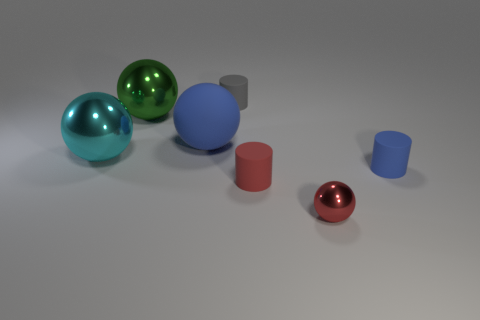There is a tiny cylinder that is the same color as the large matte thing; what is it made of?
Keep it short and to the point. Rubber. There is a big sphere that is made of the same material as the gray cylinder; what is its color?
Keep it short and to the point. Blue. The cylinder behind the metal object that is behind the big cyan shiny thing is what color?
Make the answer very short. Gray. Are there any big matte objects of the same color as the tiny shiny thing?
Provide a short and direct response. No. There is a red matte object that is the same size as the gray rubber cylinder; what is its shape?
Offer a very short reply. Cylinder. There is a big matte object that is behind the large cyan shiny thing; how many balls are right of it?
Ensure brevity in your answer.  1. Is the small metallic sphere the same color as the big matte object?
Provide a short and direct response. No. How many other things are the same material as the blue cylinder?
Offer a terse response. 3. What is the shape of the green metal thing that is behind the blue rubber thing that is on the left side of the gray rubber object?
Your answer should be compact. Sphere. What is the size of the metal sphere in front of the blue cylinder?
Give a very brief answer. Small. 